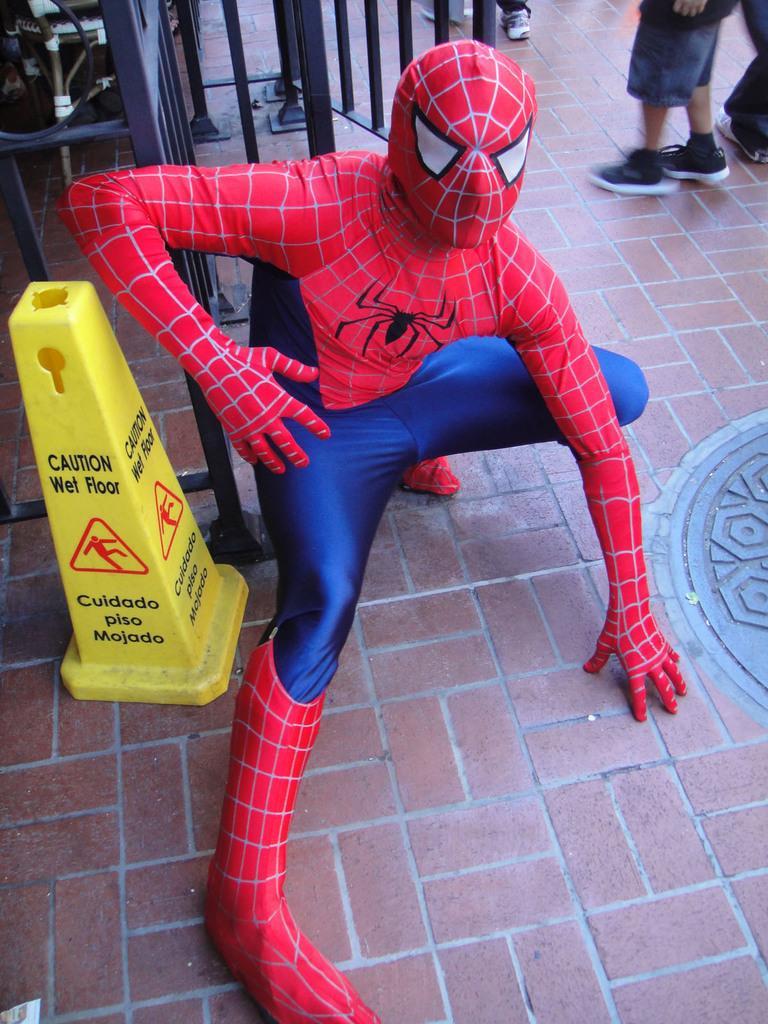Can you describe this image briefly? In this image I can see a man wearing a spider man dress. 